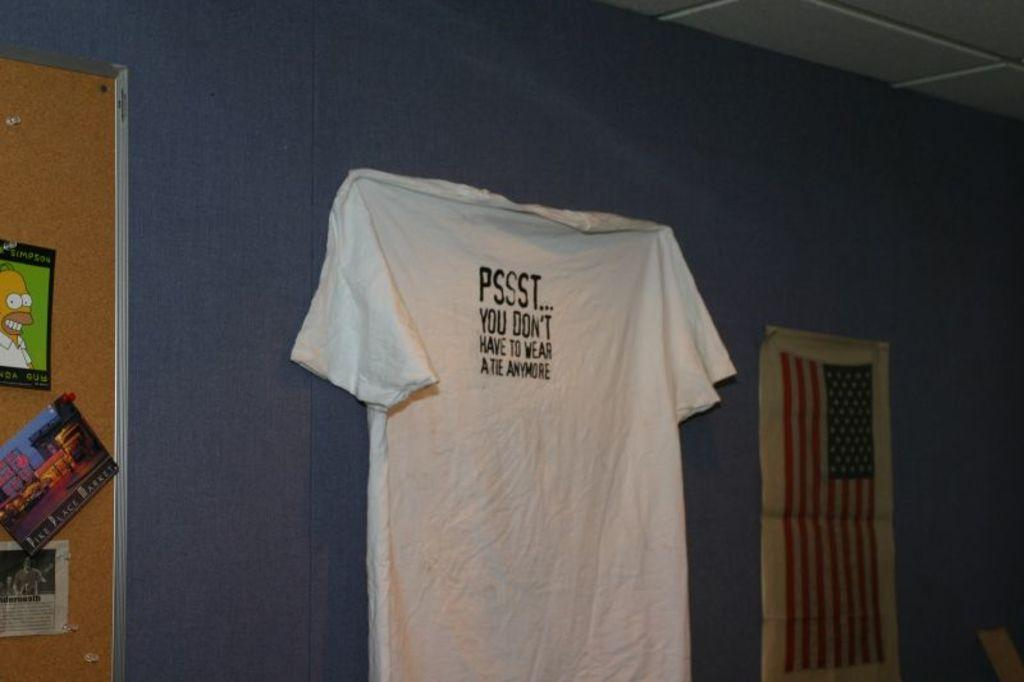What is hanging on the wall in the image? There is a shirt on the wall in the image. What color is the shirt? The shirt is white. What is located near the shirt on the wall? There is a board in the image. What can be seen on the board? There are pictures on the board. What part of the building can be seen in the image? The roof is visible in the image. How does the oven work in the image? There is no oven present in the image. What type of system is responsible for the shirt's placement on the wall? The image does not provide information about a system responsible for the shirt's placement on the wall. 